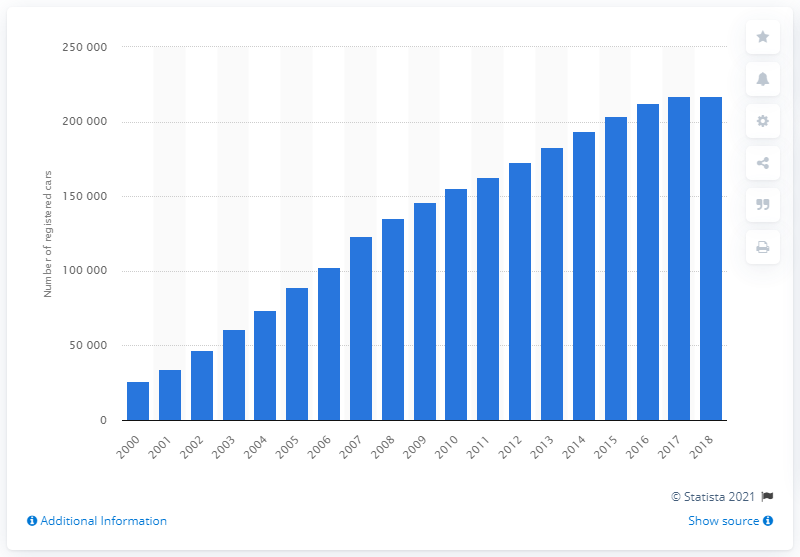Specify some key components in this picture. In 2018, there were a total of 217,389 registered cars in Great Britain. In 2000, the number of registered cars in Great Britain was 260,541. 